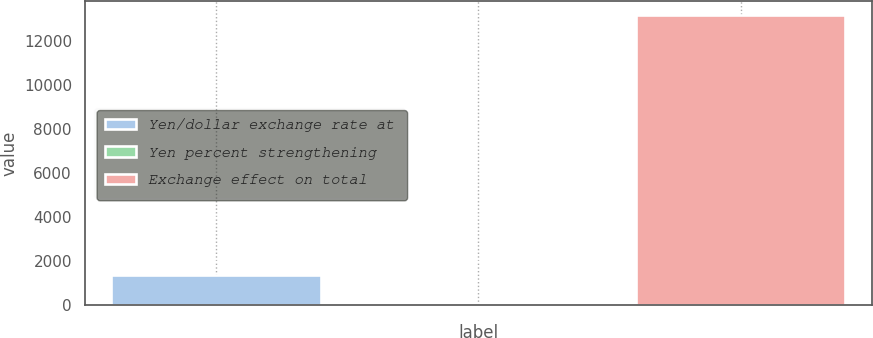Convert chart to OTSL. <chart><loc_0><loc_0><loc_500><loc_500><bar_chart><fcel>Yen/dollar exchange rate at<fcel>Yen percent strengthening<fcel>Exchange effect on total<nl><fcel>1354.06<fcel>25.4<fcel>13180<nl></chart> 